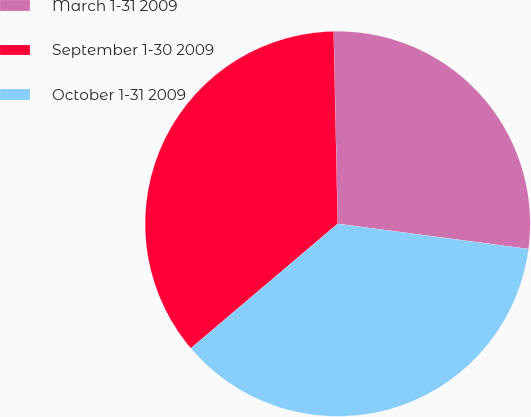<chart> <loc_0><loc_0><loc_500><loc_500><pie_chart><fcel>March 1-31 2009<fcel>September 1-30 2009<fcel>October 1-31 2009<nl><fcel>27.42%<fcel>35.86%<fcel>36.71%<nl></chart> 